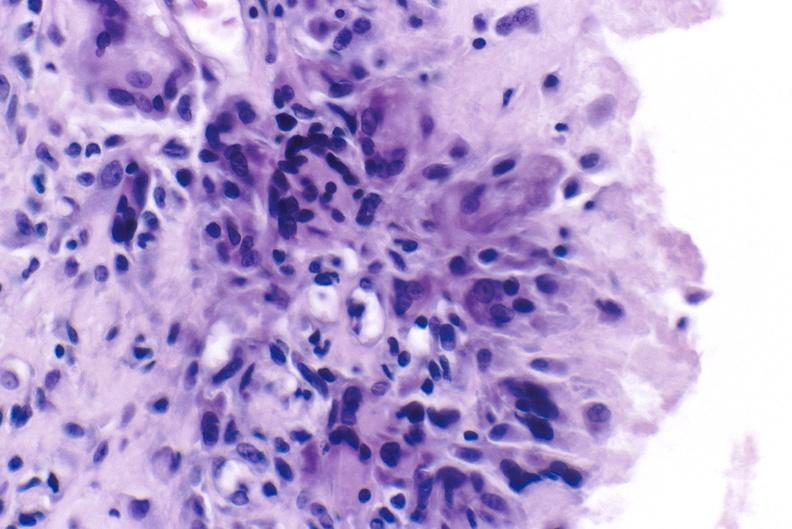what does this image show?
Answer the question using a single word or phrase. Gout 